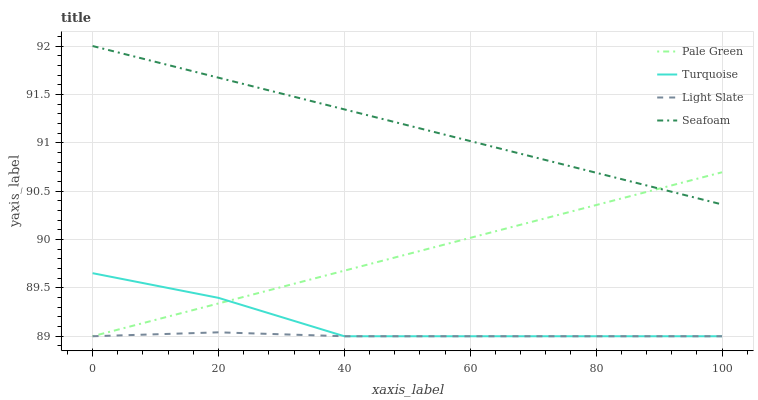Does Light Slate have the minimum area under the curve?
Answer yes or no. Yes. Does Seafoam have the maximum area under the curve?
Answer yes or no. Yes. Does Turquoise have the minimum area under the curve?
Answer yes or no. No. Does Turquoise have the maximum area under the curve?
Answer yes or no. No. Is Seafoam the smoothest?
Answer yes or no. Yes. Is Turquoise the roughest?
Answer yes or no. Yes. Is Pale Green the smoothest?
Answer yes or no. No. Is Pale Green the roughest?
Answer yes or no. No. Does Light Slate have the lowest value?
Answer yes or no. Yes. Does Seafoam have the lowest value?
Answer yes or no. No. Does Seafoam have the highest value?
Answer yes or no. Yes. Does Turquoise have the highest value?
Answer yes or no. No. Is Turquoise less than Seafoam?
Answer yes or no. Yes. Is Seafoam greater than Light Slate?
Answer yes or no. Yes. Does Turquoise intersect Pale Green?
Answer yes or no. Yes. Is Turquoise less than Pale Green?
Answer yes or no. No. Is Turquoise greater than Pale Green?
Answer yes or no. No. Does Turquoise intersect Seafoam?
Answer yes or no. No. 